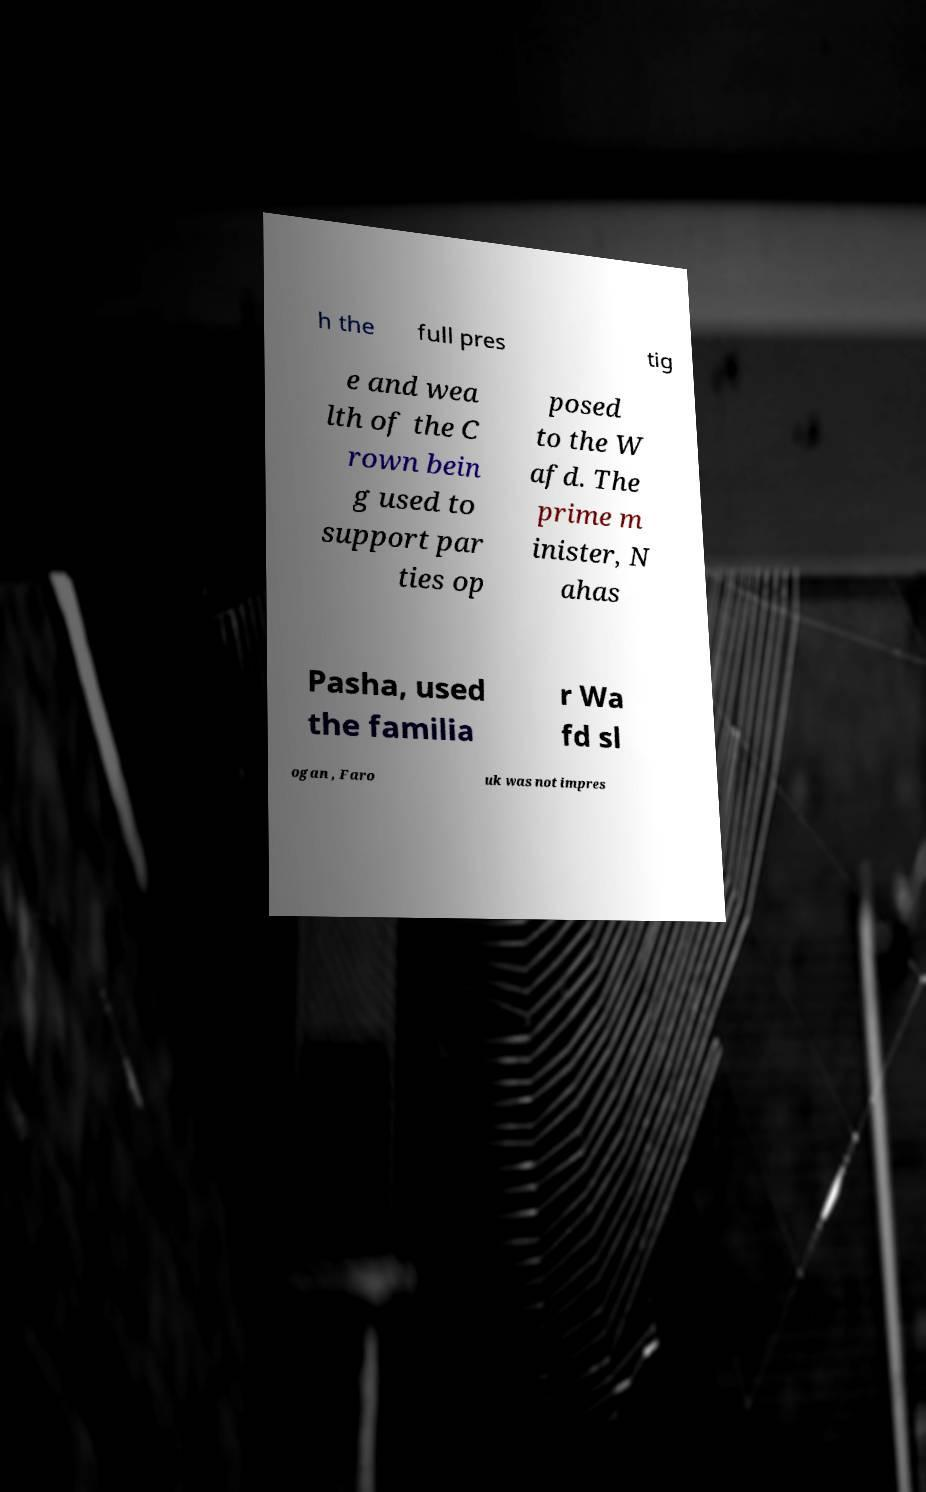Could you assist in decoding the text presented in this image and type it out clearly? h the full pres tig e and wea lth of the C rown bein g used to support par ties op posed to the W afd. The prime m inister, N ahas Pasha, used the familia r Wa fd sl ogan , Faro uk was not impres 